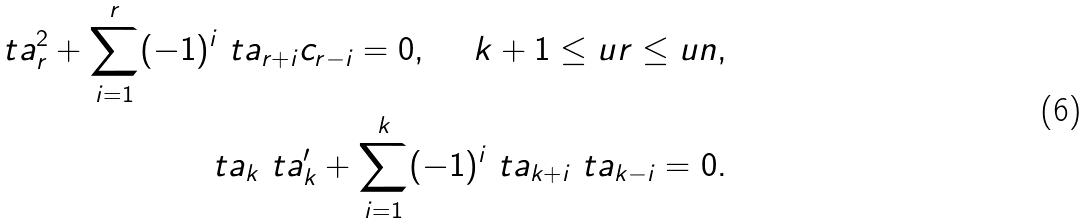Convert formula to latex. <formula><loc_0><loc_0><loc_500><loc_500>\ t a _ { r } ^ { 2 } + \sum _ { i = 1 } ^ { r } ( - 1 ) ^ { i } \ t a _ { r + i } c _ { r - i } = 0 , \ \ \ \ k + 1 \leq u r \leq u n , \\ \ t a _ { k } \ t a ^ { \prime } _ { k } + \sum _ { i = 1 } ^ { k } ( - 1 ) ^ { i } \ t a _ { k + i } \ t a _ { k - i } = 0 .</formula> 